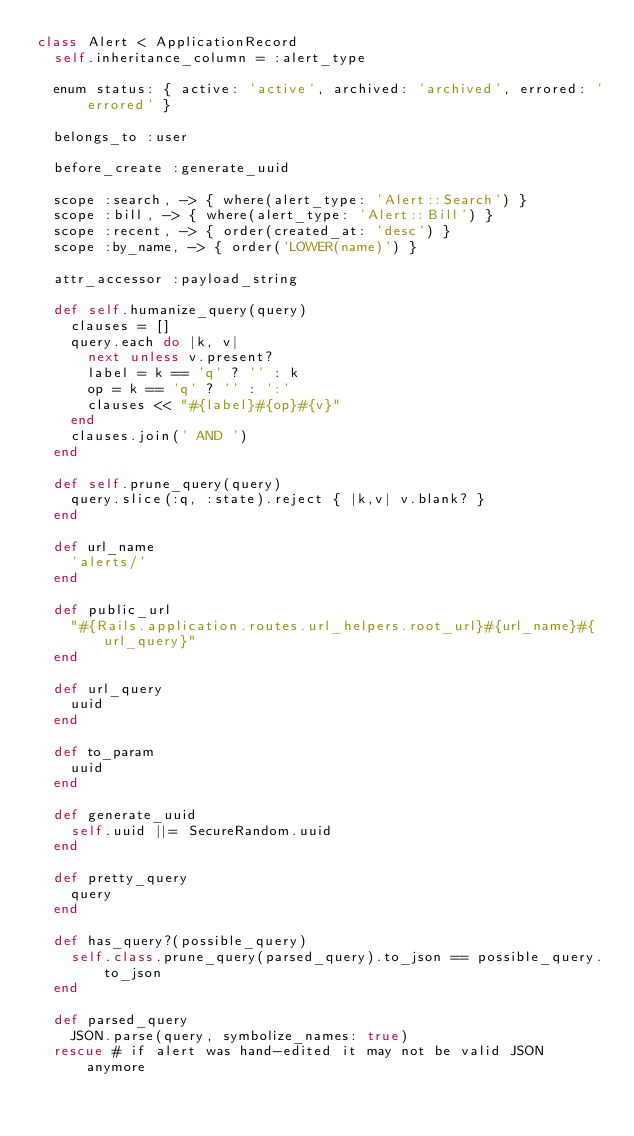<code> <loc_0><loc_0><loc_500><loc_500><_Ruby_>class Alert < ApplicationRecord
  self.inheritance_column = :alert_type

  enum status: { active: 'active', archived: 'archived', errored: 'errored' }

  belongs_to :user

  before_create :generate_uuid

  scope :search, -> { where(alert_type: 'Alert::Search') }
  scope :bill, -> { where(alert_type: 'Alert::Bill') }
  scope :recent, -> { order(created_at: 'desc') }
  scope :by_name, -> { order('LOWER(name)') }

  attr_accessor :payload_string

  def self.humanize_query(query)
    clauses = []
    query.each do |k, v|
      next unless v.present?
      label = k == 'q' ? '' : k
      op = k == 'q' ? '' : ':'
      clauses << "#{label}#{op}#{v}"
    end
    clauses.join(' AND ')
  end

  def self.prune_query(query)
    query.slice(:q, :state).reject { |k,v| v.blank? }
  end

  def url_name
    'alerts/'
  end

  def public_url
    "#{Rails.application.routes.url_helpers.root_url}#{url_name}#{url_query}"
  end

  def url_query
    uuid
  end

  def to_param
    uuid
  end

  def generate_uuid
    self.uuid ||= SecureRandom.uuid
  end

  def pretty_query
    query
  end

  def has_query?(possible_query)
    self.class.prune_query(parsed_query).to_json == possible_query.to_json
  end

  def parsed_query
    JSON.parse(query, symbolize_names: true)
  rescue # if alert was hand-edited it may not be valid JSON anymore</code> 